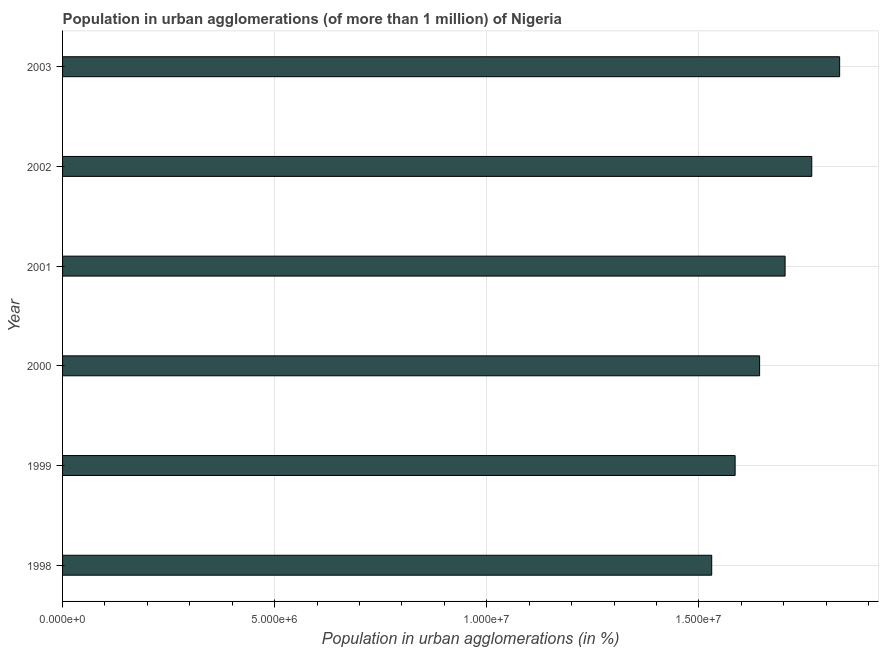Does the graph contain any zero values?
Provide a short and direct response. No. What is the title of the graph?
Give a very brief answer. Population in urban agglomerations (of more than 1 million) of Nigeria. What is the label or title of the X-axis?
Keep it short and to the point. Population in urban agglomerations (in %). What is the population in urban agglomerations in 2003?
Offer a very short reply. 1.83e+07. Across all years, what is the maximum population in urban agglomerations?
Give a very brief answer. 1.83e+07. Across all years, what is the minimum population in urban agglomerations?
Provide a short and direct response. 1.53e+07. What is the sum of the population in urban agglomerations?
Give a very brief answer. 1.01e+08. What is the difference between the population in urban agglomerations in 1998 and 2002?
Make the answer very short. -2.36e+06. What is the average population in urban agglomerations per year?
Provide a short and direct response. 1.68e+07. What is the median population in urban agglomerations?
Ensure brevity in your answer.  1.67e+07. In how many years, is the population in urban agglomerations greater than 8000000 %?
Provide a succinct answer. 6. Do a majority of the years between 1998 and 2000 (inclusive) have population in urban agglomerations greater than 10000000 %?
Offer a terse response. Yes. What is the ratio of the population in urban agglomerations in 2002 to that in 2003?
Your response must be concise. 0.96. Is the population in urban agglomerations in 2002 less than that in 2003?
Your answer should be compact. Yes. What is the difference between the highest and the second highest population in urban agglomerations?
Your answer should be very brief. 6.57e+05. Is the sum of the population in urban agglomerations in 1999 and 2001 greater than the maximum population in urban agglomerations across all years?
Your answer should be very brief. Yes. What is the difference between the highest and the lowest population in urban agglomerations?
Provide a succinct answer. 3.02e+06. What is the difference between two consecutive major ticks on the X-axis?
Your response must be concise. 5.00e+06. What is the Population in urban agglomerations (in %) in 1998?
Your answer should be compact. 1.53e+07. What is the Population in urban agglomerations (in %) in 1999?
Your response must be concise. 1.59e+07. What is the Population in urban agglomerations (in %) in 2000?
Keep it short and to the point. 1.64e+07. What is the Population in urban agglomerations (in %) of 2001?
Offer a terse response. 1.70e+07. What is the Population in urban agglomerations (in %) in 2002?
Your answer should be compact. 1.77e+07. What is the Population in urban agglomerations (in %) in 2003?
Provide a succinct answer. 1.83e+07. What is the difference between the Population in urban agglomerations (in %) in 1998 and 1999?
Your response must be concise. -5.52e+05. What is the difference between the Population in urban agglomerations (in %) in 1998 and 2000?
Make the answer very short. -1.13e+06. What is the difference between the Population in urban agglomerations (in %) in 1998 and 2001?
Provide a succinct answer. -1.73e+06. What is the difference between the Population in urban agglomerations (in %) in 1998 and 2002?
Your response must be concise. -2.36e+06. What is the difference between the Population in urban agglomerations (in %) in 1998 and 2003?
Offer a very short reply. -3.02e+06. What is the difference between the Population in urban agglomerations (in %) in 1999 and 2000?
Provide a succinct answer. -5.77e+05. What is the difference between the Population in urban agglomerations (in %) in 1999 and 2001?
Offer a terse response. -1.18e+06. What is the difference between the Population in urban agglomerations (in %) in 1999 and 2002?
Offer a very short reply. -1.81e+06. What is the difference between the Population in urban agglomerations (in %) in 1999 and 2003?
Your answer should be very brief. -2.46e+06. What is the difference between the Population in urban agglomerations (in %) in 2000 and 2001?
Your answer should be compact. -6.01e+05. What is the difference between the Population in urban agglomerations (in %) in 2000 and 2002?
Your answer should be very brief. -1.23e+06. What is the difference between the Population in urban agglomerations (in %) in 2000 and 2003?
Ensure brevity in your answer.  -1.89e+06. What is the difference between the Population in urban agglomerations (in %) in 2001 and 2002?
Offer a very short reply. -6.29e+05. What is the difference between the Population in urban agglomerations (in %) in 2001 and 2003?
Offer a terse response. -1.29e+06. What is the difference between the Population in urban agglomerations (in %) in 2002 and 2003?
Provide a short and direct response. -6.57e+05. What is the ratio of the Population in urban agglomerations (in %) in 1998 to that in 2000?
Provide a short and direct response. 0.93. What is the ratio of the Population in urban agglomerations (in %) in 1998 to that in 2001?
Provide a succinct answer. 0.9. What is the ratio of the Population in urban agglomerations (in %) in 1998 to that in 2002?
Your answer should be very brief. 0.87. What is the ratio of the Population in urban agglomerations (in %) in 1998 to that in 2003?
Provide a succinct answer. 0.83. What is the ratio of the Population in urban agglomerations (in %) in 1999 to that in 2002?
Your answer should be compact. 0.9. What is the ratio of the Population in urban agglomerations (in %) in 1999 to that in 2003?
Your answer should be compact. 0.87. What is the ratio of the Population in urban agglomerations (in %) in 2000 to that in 2002?
Ensure brevity in your answer.  0.93. What is the ratio of the Population in urban agglomerations (in %) in 2000 to that in 2003?
Provide a short and direct response. 0.9. What is the ratio of the Population in urban agglomerations (in %) in 2001 to that in 2002?
Keep it short and to the point. 0.96. What is the ratio of the Population in urban agglomerations (in %) in 2002 to that in 2003?
Your response must be concise. 0.96. 